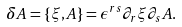<formula> <loc_0><loc_0><loc_500><loc_500>\delta A = \{ \xi , A \} = \epsilon ^ { r s } \partial _ { r } \xi \partial _ { s } A .</formula> 